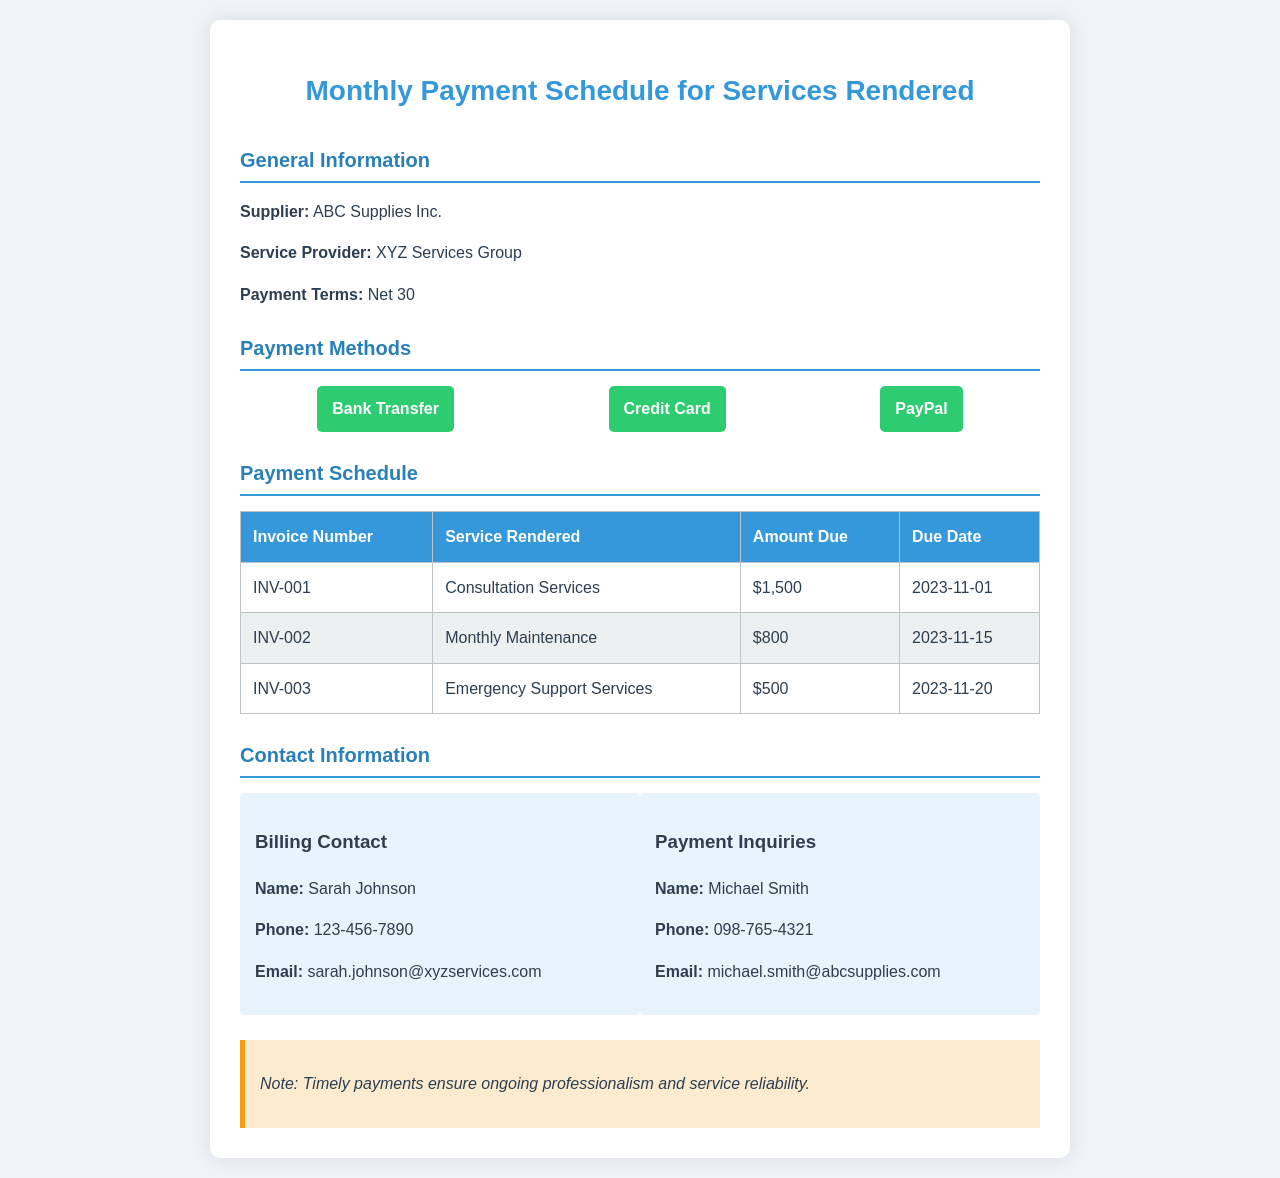What is the payment term? The payment term is specified in the document as "Net 30."
Answer: Net 30 Who is the billing contact? The billing contact's name is listed in the contact information section.
Answer: Sarah Johnson What is the amount due for the Emergency Support Services? The amount due is found in the payment schedule table for the corresponding service.
Answer: $500 What is the due date for Invoice Number INV-002? This information can be found in the payment schedule section of the document.
Answer: 2023-11-15 Which payment method is not mentioned in the document? This question encourages reasoning about the stated payment methods.
Answer: Cash How many services are listed in the payment schedule? The document outlines multiple services rendered along with their payment details.
Answer: 3 What is the service rendered for Invoice Number INV-001? This information can be seen in the payment schedule under the corresponding invoice number.
Answer: Consultation Services What payment methods are accepted? The document includes a section that lists various accepted payment options.
Answer: Bank Transfer, Credit Card, PayPal What is the phone number of the payment inquiries contact? This information is stated under the contact information for payment inquiries.
Answer: 098-765-4321 